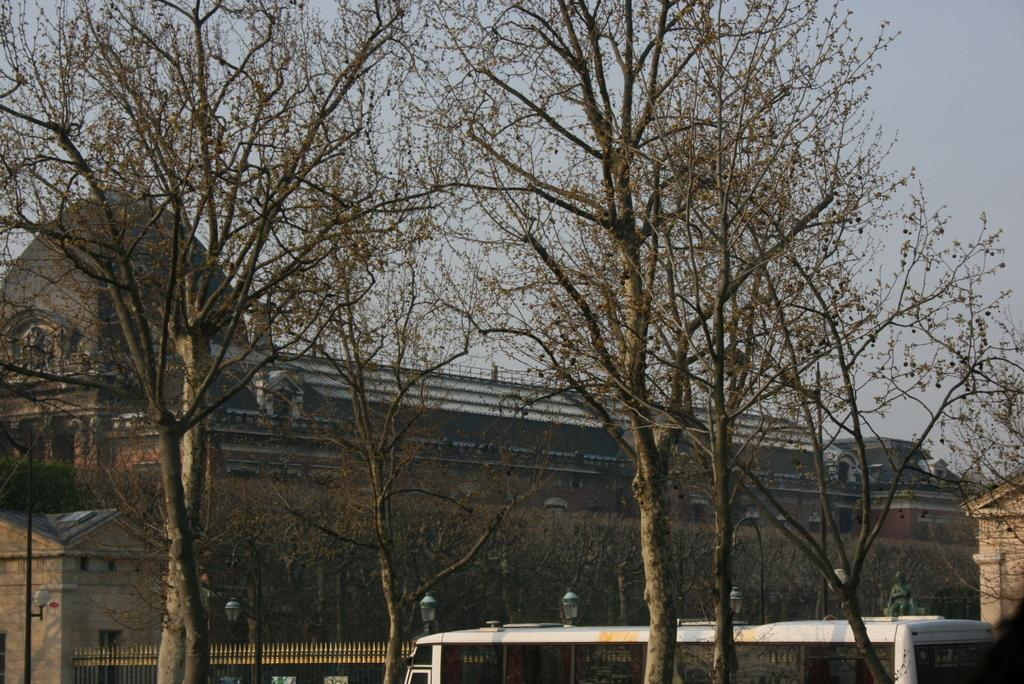What type of vegetation can be seen in the image? There are trees in the image. What structure is present in the image? There is a gate in the image. What can be used for illumination in the image? There are lights in the image. What mode of transportation is visible in the image? There is a bus in the image. What type of structure is present in the image? There is a building in the image. What is visible in the background of the image? The sky is visible in the image. Can you see any docks in the image? There is no dock present in the image. How many fingers are visible in the image? There are no fingers visible in the image. 